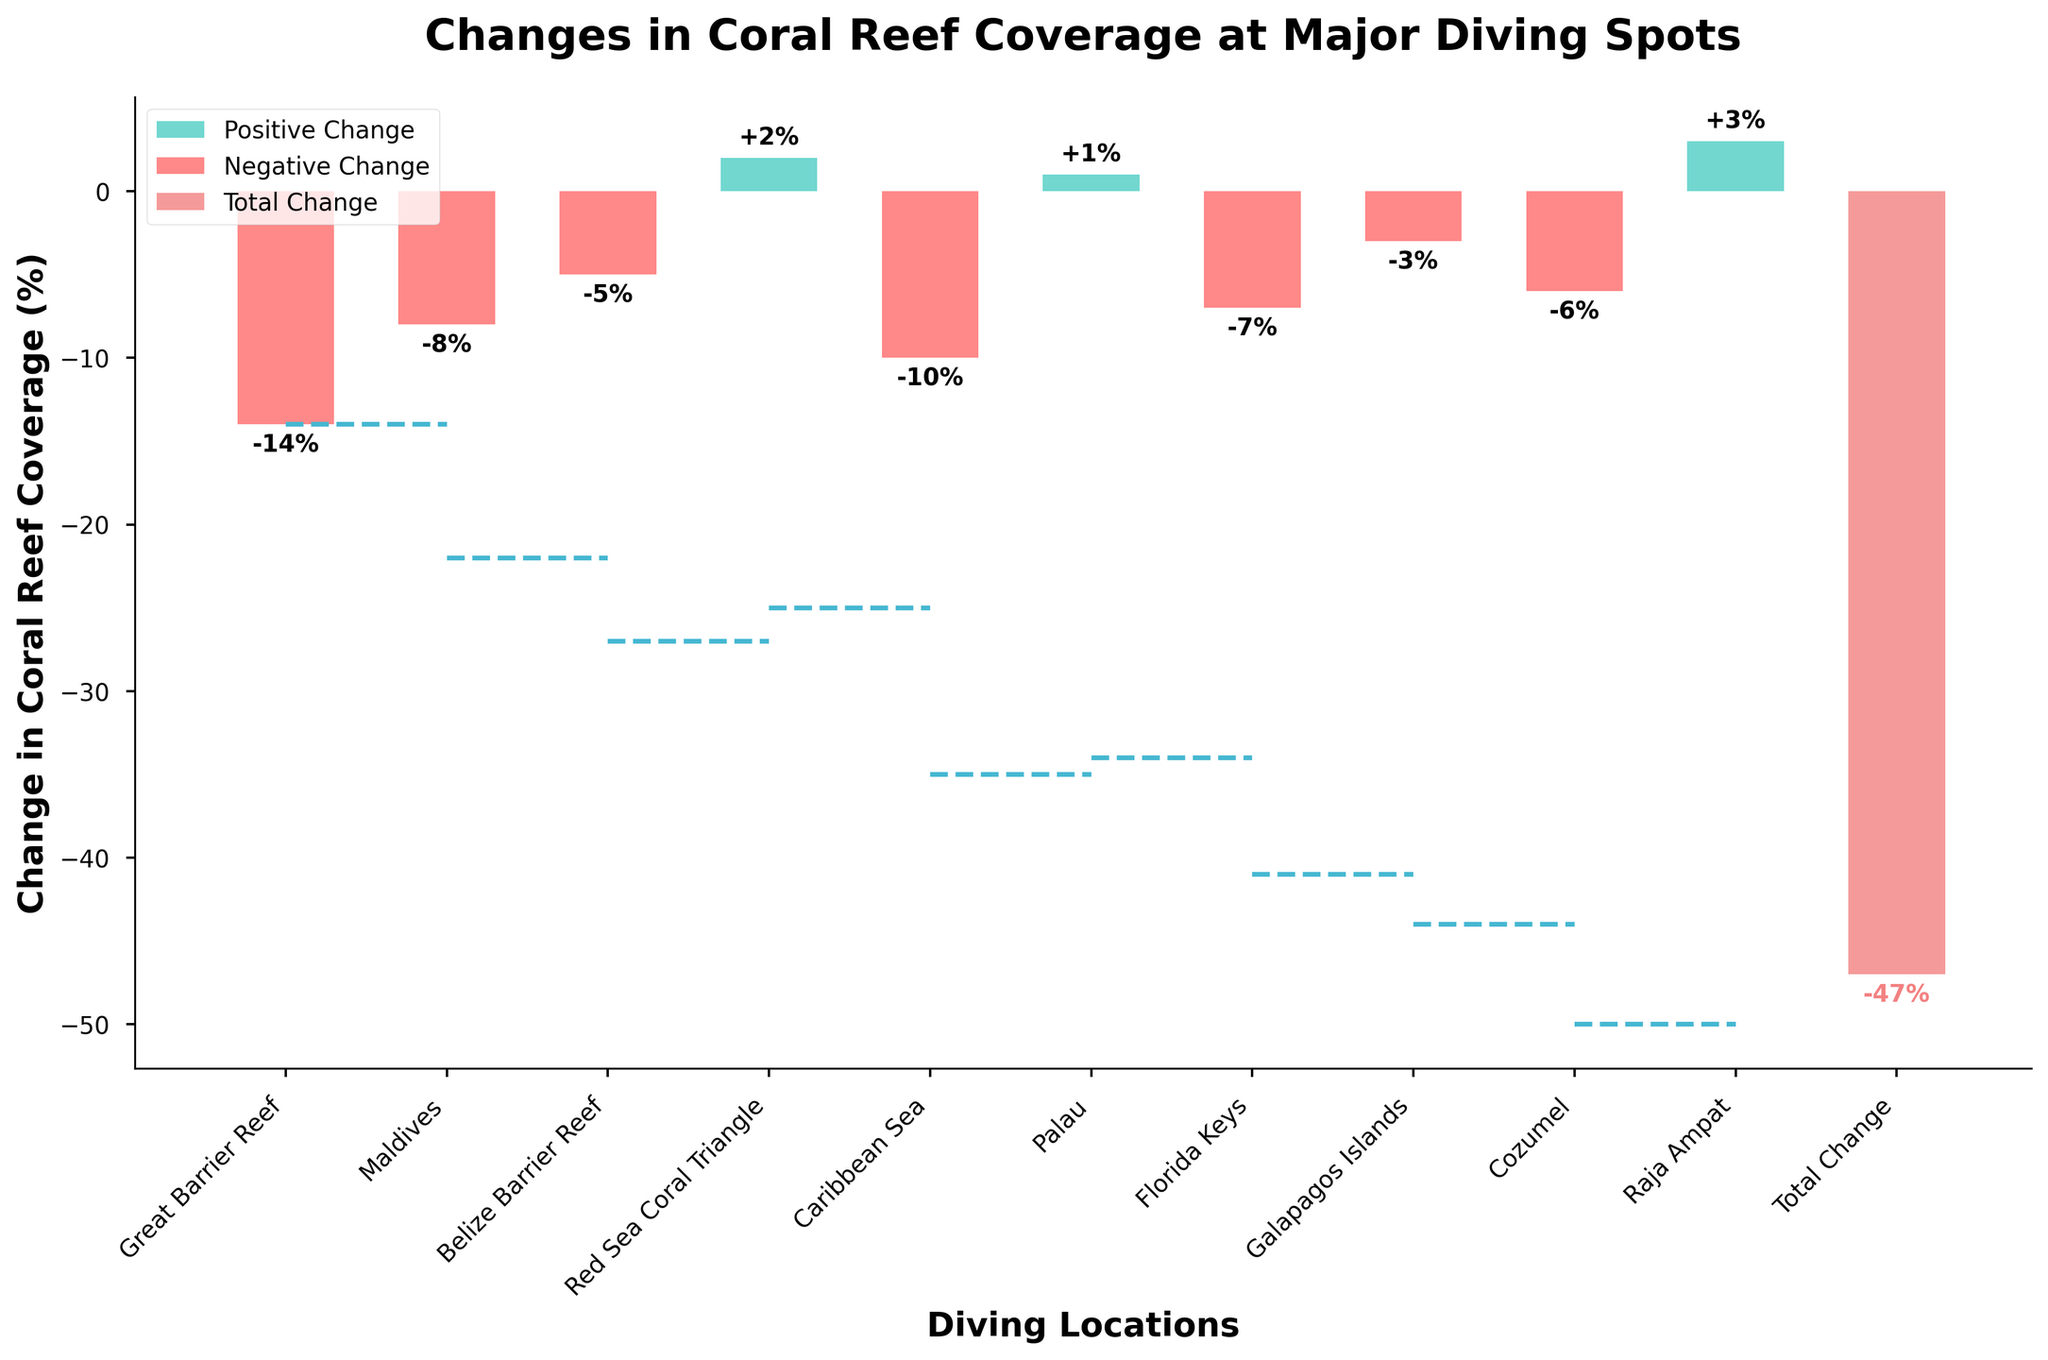Which location has the highest positive change in coral reef coverage? To find the location with the highest positive change, observe the bars above the x-axis. The maximum positive value is +3% found at Raja Ampat.
Answer: Raja Ampat Which location has the greatest decrease in coral reef coverage? Identify the location with the lowest negative change by observing the bars below the x-axis. The Great Barrier Reef shows the greatest decrease at -14%.
Answer: Great Barrier Reef What is the total change in coral reef coverage across all diving spots? The 'Total Change' bar at the end of the waterfall chart summarizes the cumulative change. It is -47%.
Answer: -47% How many locations experienced a positive change in coral reef coverage? Count the number of bars that are above the x-axis. There are three locations: Red Sea Coral Triangle (+2%), Palau (+1%), and Raja Ampat (+3%).
Answer: 3 What is the average change in coral reef coverage across all the individual diving spots? Sum all the individual changes: (-14) + (-8) + (-5) + 2 + (-10) + 1 + (-7) + (-3) + (-6) + 3 = -47, then divide by the number of locations (10).
Answer: -4.7% Which two locations have similar changes in coral reef coverage, and what is their value? Look for locations with roughly the same bar height. Palau (+1%) and Red Sea Coral Triangle (+2%) have similar positive changes.
Answer: Palau and Red Sea Coral Triangle Combine the changes in coverage for the Great Barrier Reef and the Florida Keys. What is the result? Sum the changes of these two locations: -14 + (-7) = -21.
Answer: -21% Compare the changes in coral reef coverage in the Caribbean Sea and Cozumel. Which one is greater? Observe the negative values for these two locations: Caribbean Sea (-10) and Cozumel (-6). Cozumel has a less negative (greater) change.
Answer: Cozumel If Raja Ampat were excluded, what would be the new total change in coral reef coverage? Remove Raja Ampat's +3% from the total -47%: (-47) - 3 = -50.
Answer: -50 